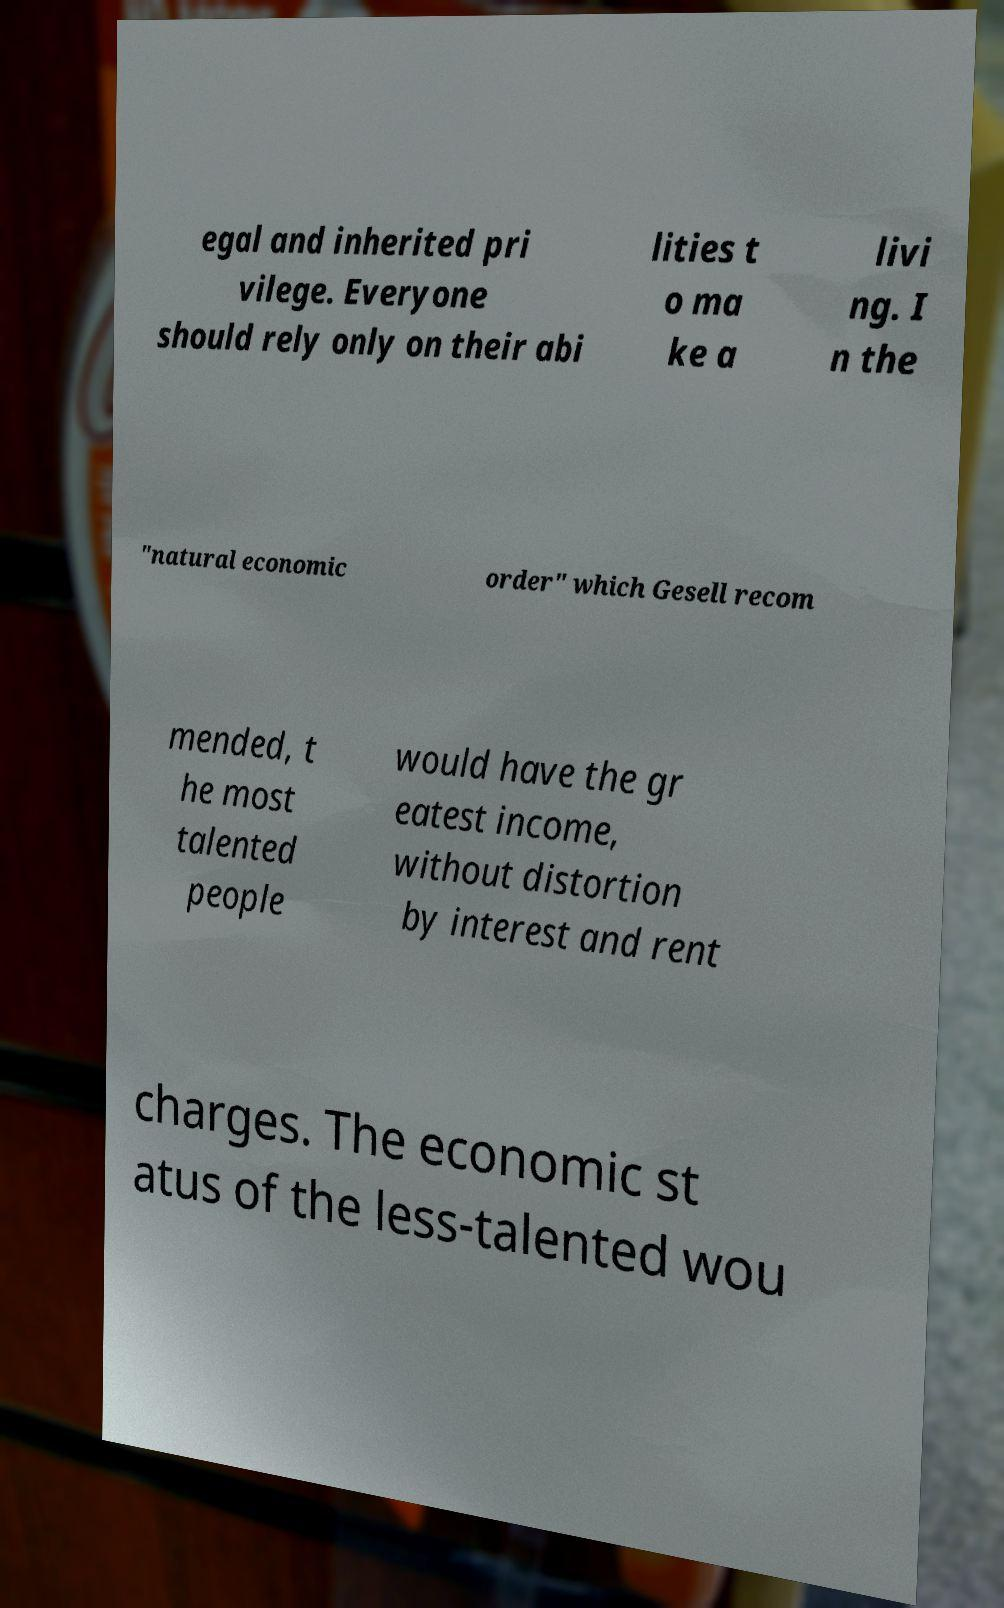For documentation purposes, I need the text within this image transcribed. Could you provide that? egal and inherited pri vilege. Everyone should rely only on their abi lities t o ma ke a livi ng. I n the "natural economic order" which Gesell recom mended, t he most talented people would have the gr eatest income, without distortion by interest and rent charges. The economic st atus of the less-talented wou 